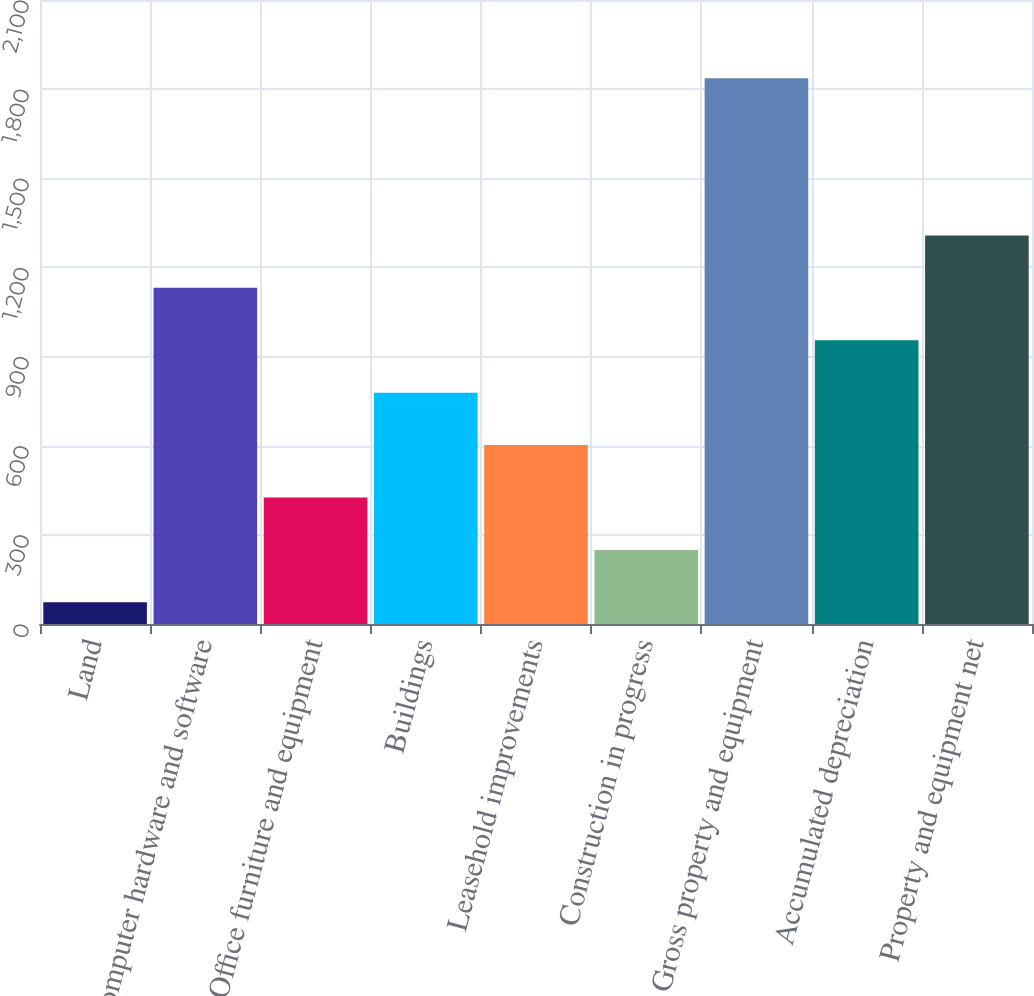Convert chart. <chart><loc_0><loc_0><loc_500><loc_500><bar_chart><fcel>Land<fcel>Computer hardware and software<fcel>Office furniture and equipment<fcel>Buildings<fcel>Leasehold improvements<fcel>Construction in progress<fcel>Gross property and equipment<fcel>Accumulated depreciation<fcel>Property and equipment net<nl><fcel>73<fcel>1131.4<fcel>425.8<fcel>778.6<fcel>602.2<fcel>249.4<fcel>1837<fcel>955<fcel>1307.8<nl></chart> 